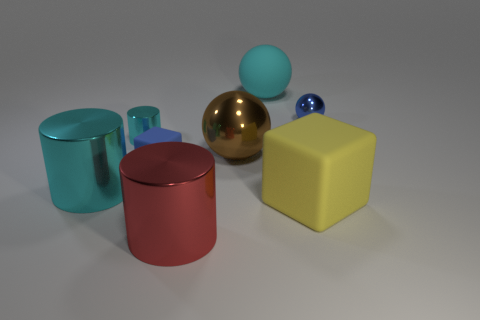Are there any other things of the same color as the big matte block?
Offer a very short reply. No. There is a large rubber thing on the right side of the cyan object right of the large thing that is in front of the large yellow object; what color is it?
Your answer should be very brief. Yellow. Do the blue cube and the cyan ball have the same size?
Offer a very short reply. No. What number of purple metallic cylinders are the same size as the blue metallic thing?
Your answer should be very brief. 0. There is another small object that is the same color as the tiny matte thing; what is its shape?
Your answer should be very brief. Sphere. Is the material of the tiny blue object that is in front of the small blue metal sphere the same as the sphere on the left side of the cyan sphere?
Keep it short and to the point. No. Is there anything else that is the same shape as the blue matte thing?
Your answer should be compact. Yes. What is the color of the small matte thing?
Ensure brevity in your answer.  Blue. What number of other small things are the same shape as the yellow rubber thing?
Keep it short and to the point. 1. There is a cube that is the same size as the cyan rubber thing; what color is it?
Offer a very short reply. Yellow. 